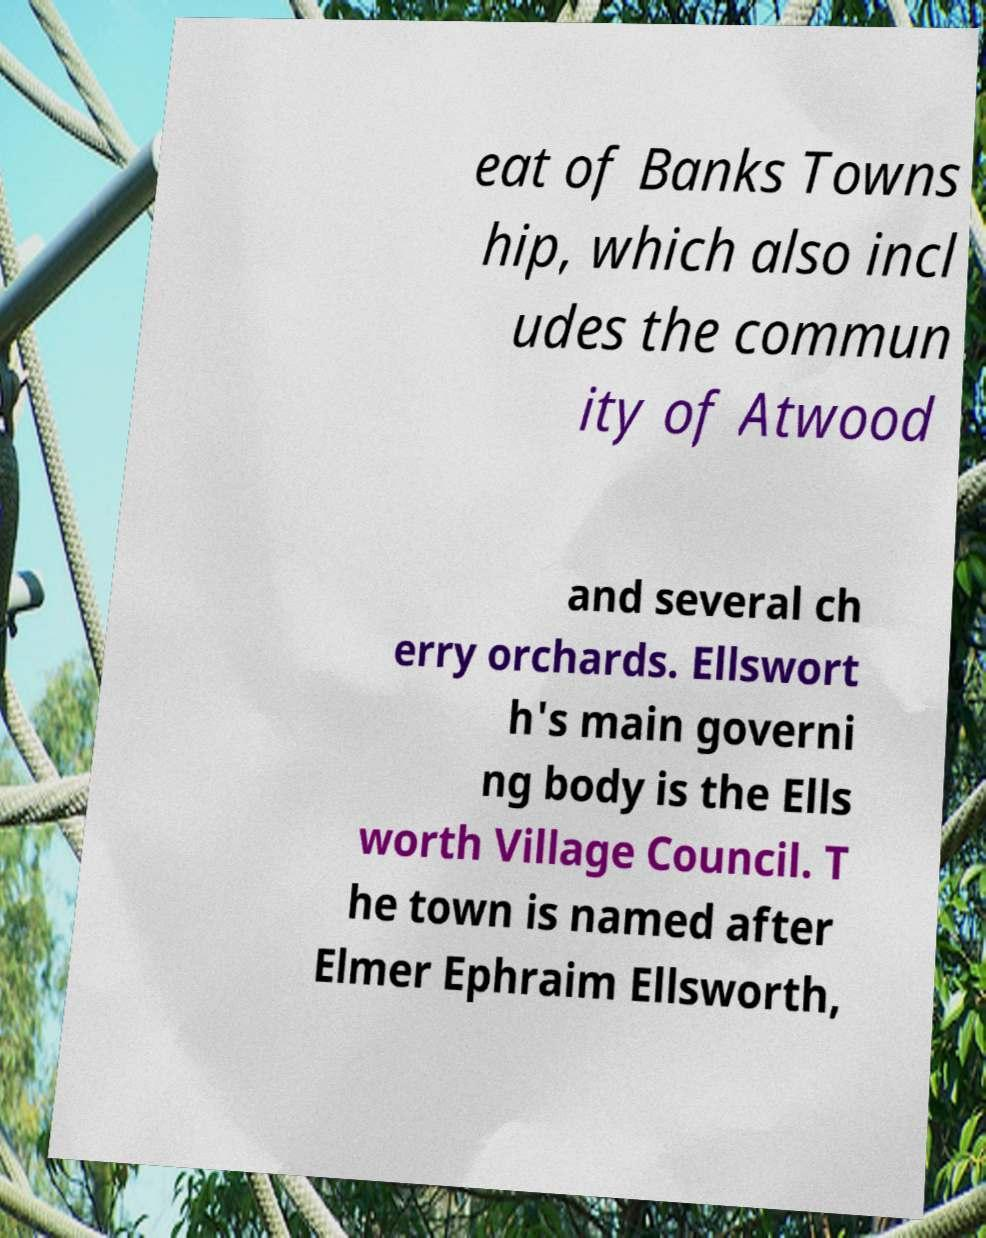Could you assist in decoding the text presented in this image and type it out clearly? eat of Banks Towns hip, which also incl udes the commun ity of Atwood and several ch erry orchards. Ellswort h's main governi ng body is the Ells worth Village Council. T he town is named after Elmer Ephraim Ellsworth, 